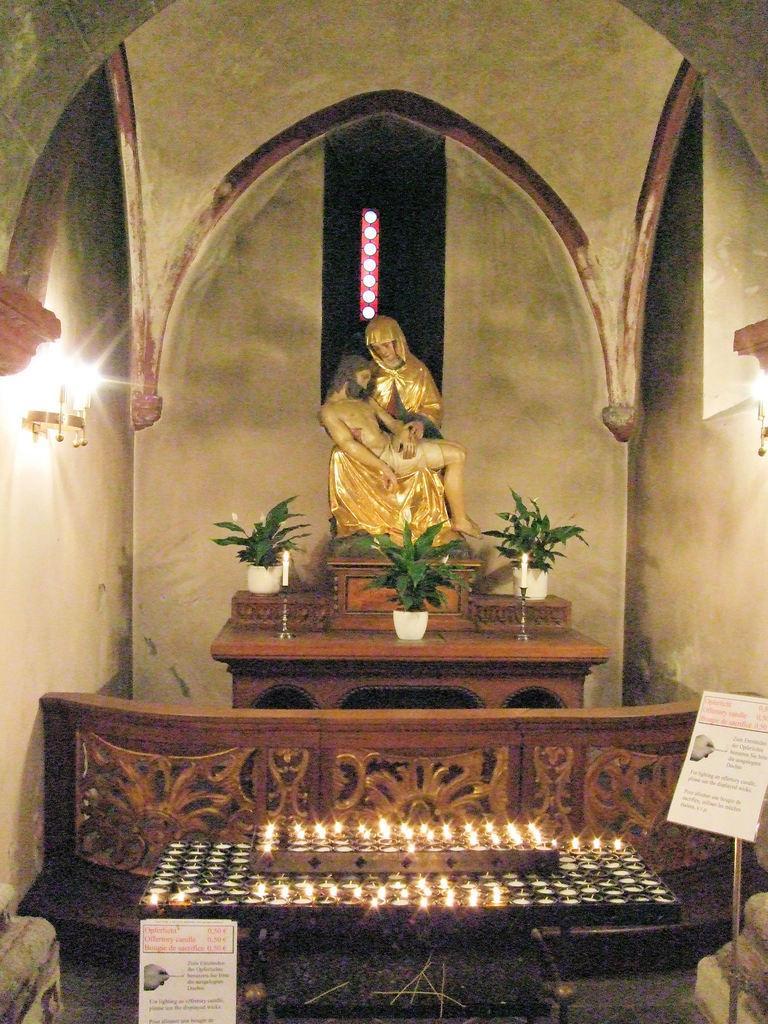How would you summarize this image in a sentence or two? In this image we can see a statue placed on a cupboard on which two candles and group of plants are placed. In the background we can see lights placed on the walls. 